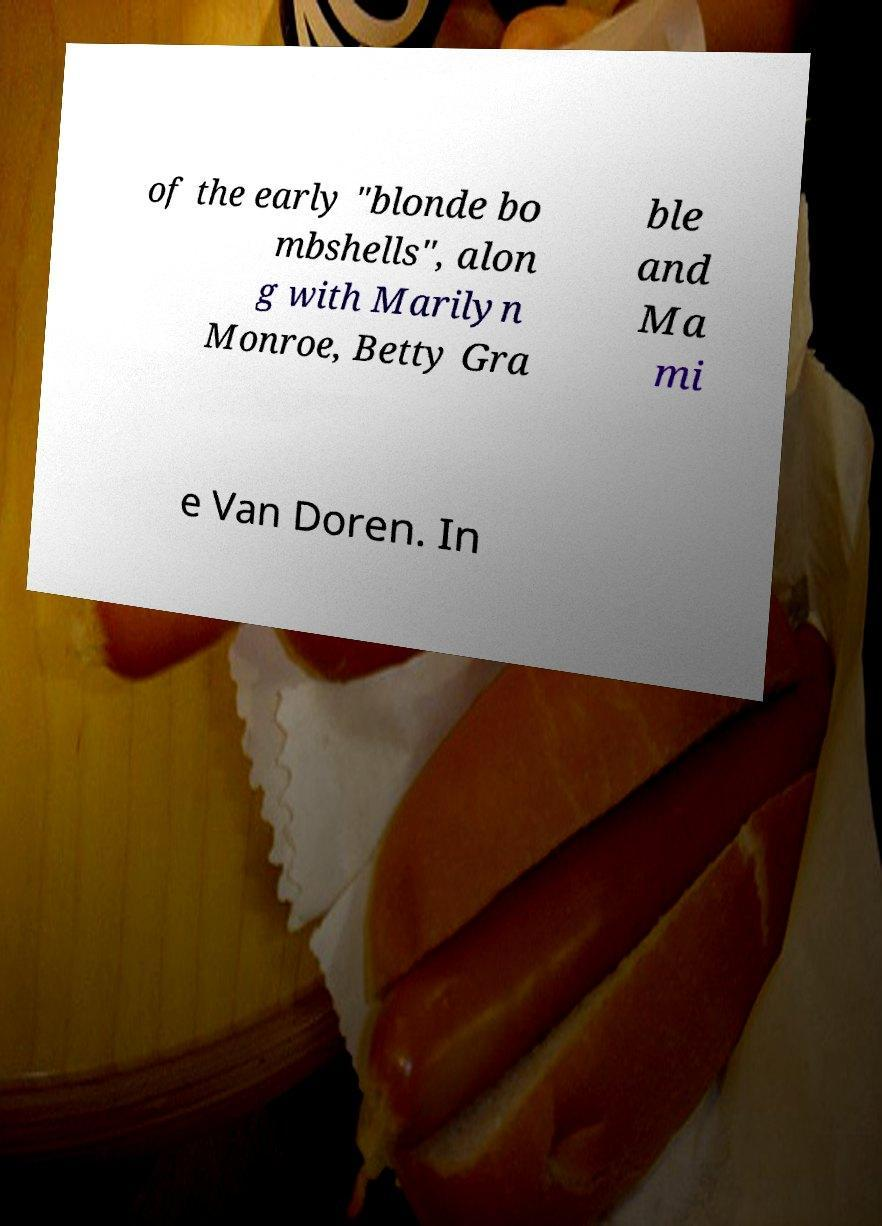Could you extract and type out the text from this image? of the early "blonde bo mbshells", alon g with Marilyn Monroe, Betty Gra ble and Ma mi e Van Doren. In 